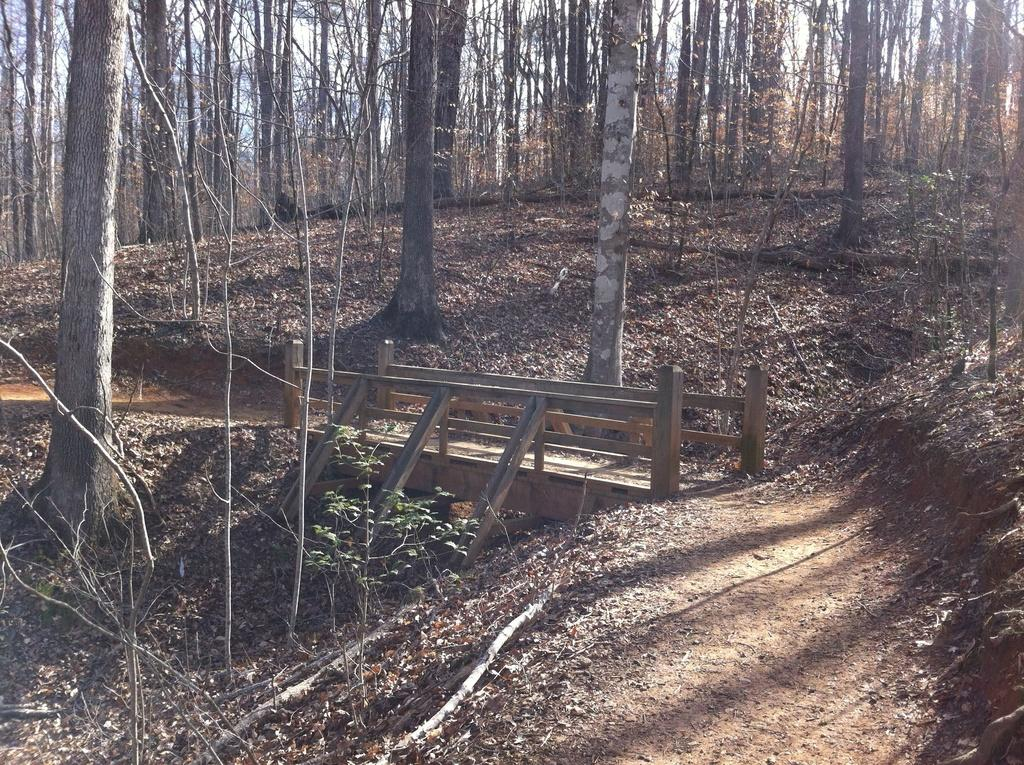What type of natural environment is depicted in the image? There is a forest in the image. What structure can be seen in the middle of the image? There is a bridge in the middle of the image. What type of pancake is being served on the sheet in the image? There is no pancake or sheet present in the image; it features a forest and a bridge. 